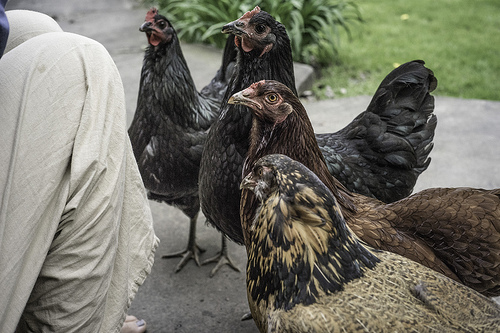<image>
Is the hen to the left of the hen? Yes. From this viewpoint, the hen is positioned to the left side relative to the hen. 